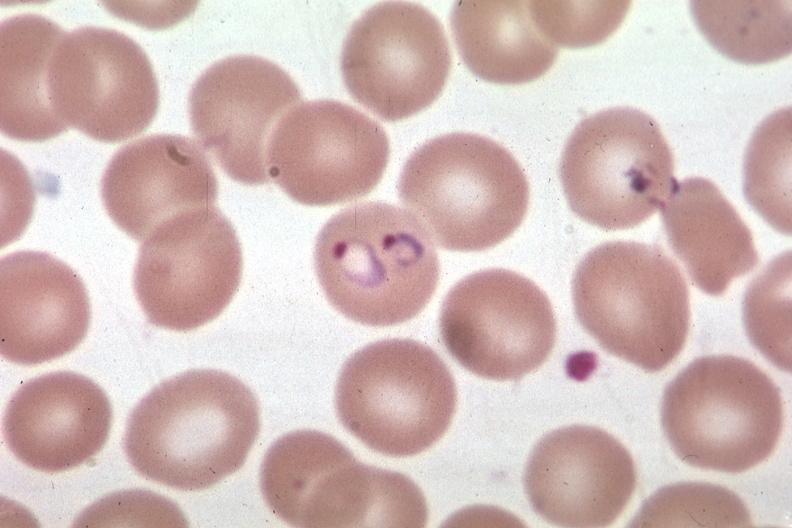s malaria plasmodium vivax present?
Answer the question using a single word or phrase. Yes 